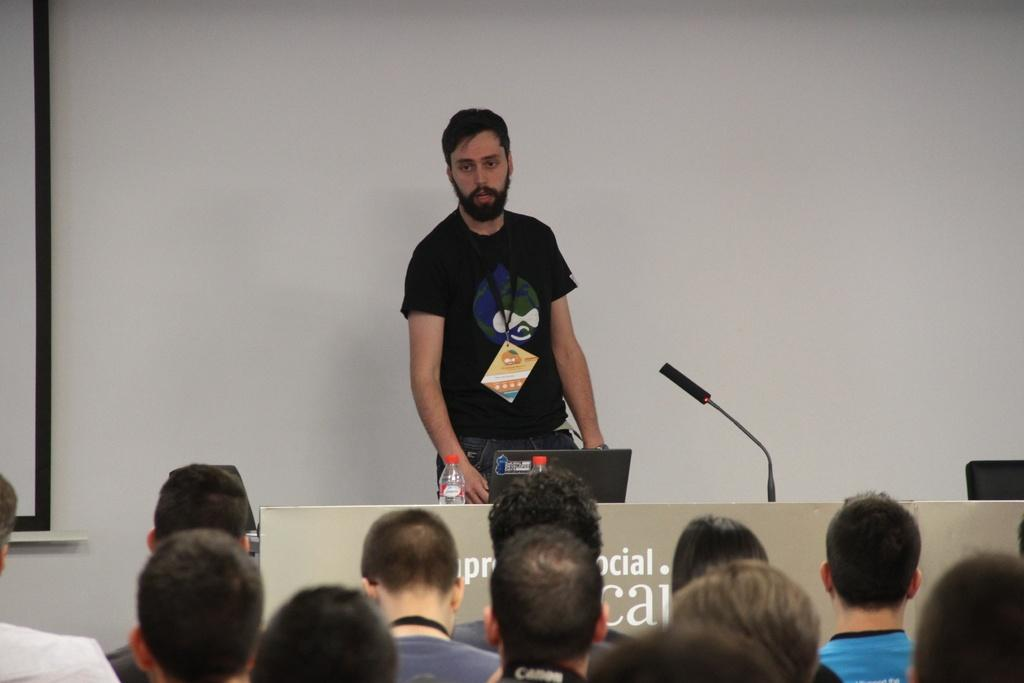What is the man in the image wearing? The man is wearing a black t-shirt. Where is the man located in the image? The man is standing in front of a table. What objects are on the table in the image? There is a microphone, a laptop, and water bottles on the table. What are the people in the background doing? The people in the background are staring at the man. What type of gold toy can be seen on the railway in the image? There is no gold toy or railway present in the image. 